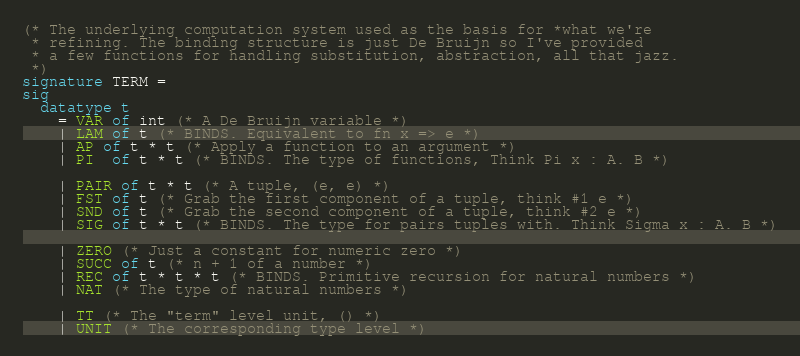<code> <loc_0><loc_0><loc_500><loc_500><_SML_>(* The underlying computation system used as the basis for *what we're
 * refining. The binding structure is just De Bruijn so I've provided
 * a few functions for handling substitution, abstraction, all that jazz.
 *)
signature TERM =
sig
  datatype t
    = VAR of int (* A De Bruijn variable *)
    | LAM of t (* BINDS. Equivalent to fn x => e *)
    | AP of t * t (* Apply a function to an argument *)
    | PI  of t * t (* BINDS. The type of functions, Think Pi x : A. B *)

    | PAIR of t * t (* A tuple, (e, e) *)
    | FST of t (* Grab the first component of a tuple, think #1 e *)
    | SND of t (* Grab the second component of a tuple, think #2 e *)
    | SIG of t * t (* BINDS. The type for pairs tuples with. Think Sigma x : A. B *)

    | ZERO (* Just a constant for numeric zero *)
    | SUCC of t (* n + 1 of a number *)
    | REC of t * t * t (* BINDS. Primitive recursion for natural numbers *)
    | NAT (* The type of natural numbers *)

    | TT (* The "term" level unit, () *)
    | UNIT (* The corresponding type level *)
</code> 